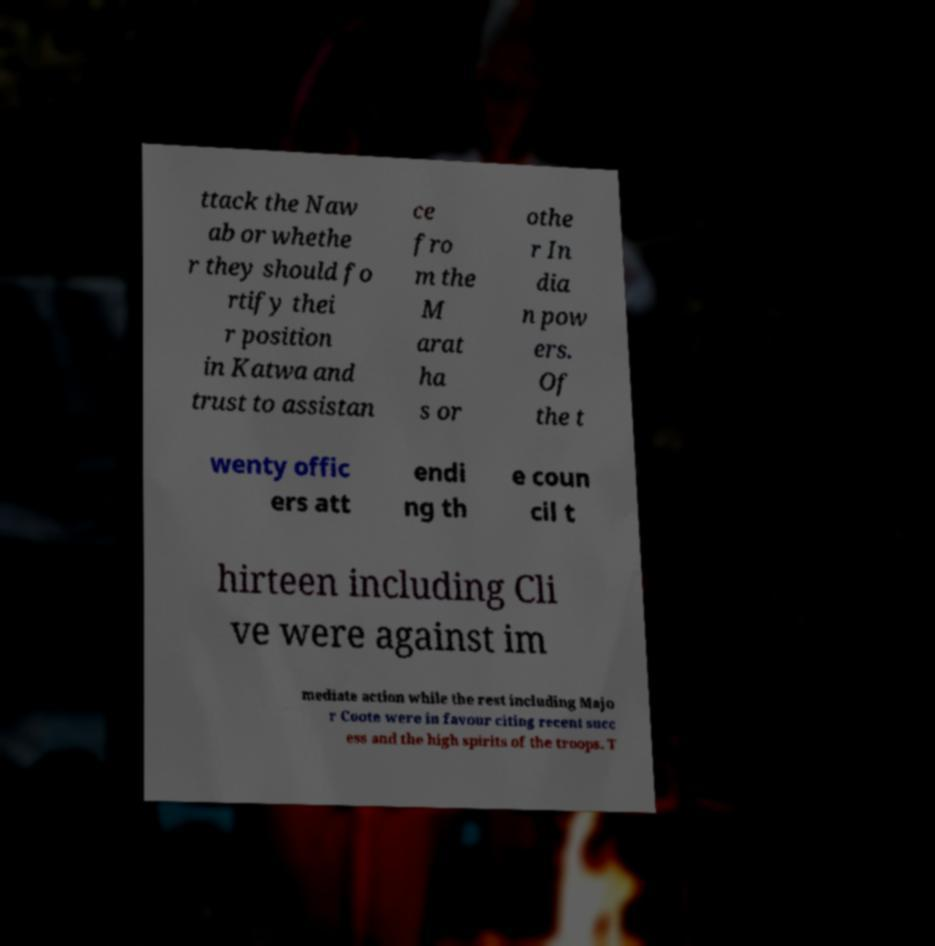Please identify and transcribe the text found in this image. ttack the Naw ab or whethe r they should fo rtify thei r position in Katwa and trust to assistan ce fro m the M arat ha s or othe r In dia n pow ers. Of the t wenty offic ers att endi ng th e coun cil t hirteen including Cli ve were against im mediate action while the rest including Majo r Coote were in favour citing recent succ ess and the high spirits of the troops. T 